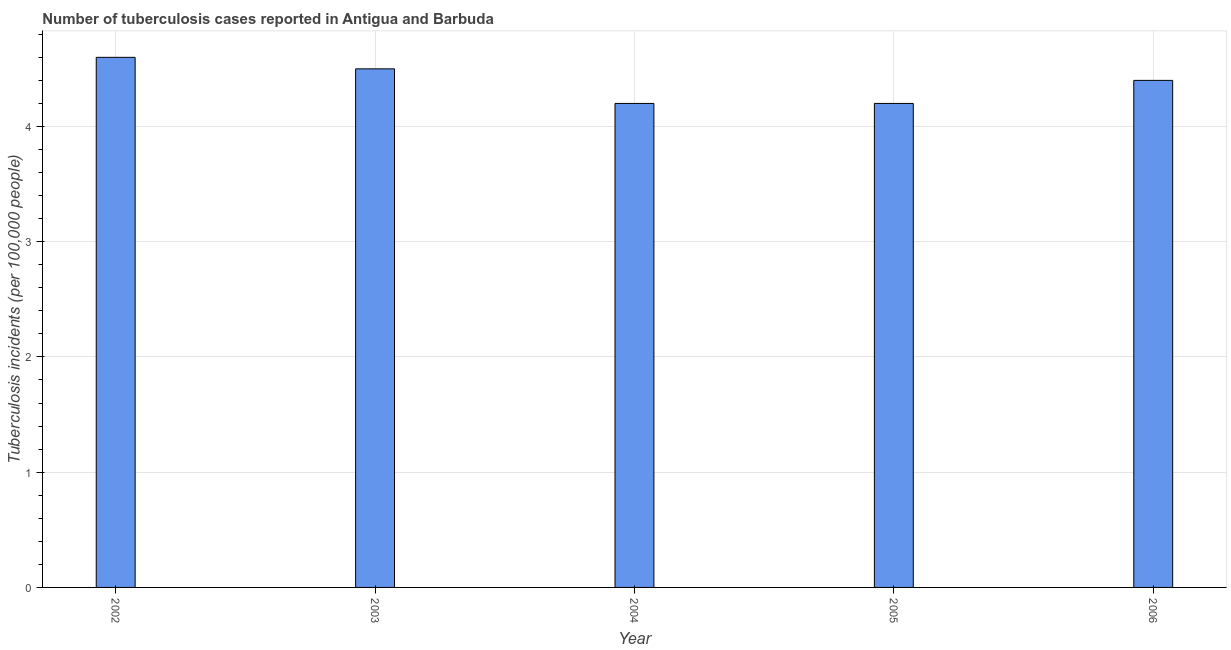Does the graph contain grids?
Your response must be concise. Yes. What is the title of the graph?
Offer a very short reply. Number of tuberculosis cases reported in Antigua and Barbuda. What is the label or title of the X-axis?
Ensure brevity in your answer.  Year. What is the label or title of the Y-axis?
Your answer should be very brief. Tuberculosis incidents (per 100,0 people). Across all years, what is the maximum number of tuberculosis incidents?
Your answer should be very brief. 4.6. Across all years, what is the minimum number of tuberculosis incidents?
Make the answer very short. 4.2. In which year was the number of tuberculosis incidents maximum?
Give a very brief answer. 2002. In which year was the number of tuberculosis incidents minimum?
Keep it short and to the point. 2004. What is the sum of the number of tuberculosis incidents?
Your answer should be compact. 21.9. What is the difference between the number of tuberculosis incidents in 2002 and 2005?
Ensure brevity in your answer.  0.4. What is the average number of tuberculosis incidents per year?
Ensure brevity in your answer.  4.38. What is the ratio of the number of tuberculosis incidents in 2003 to that in 2005?
Offer a terse response. 1.07. Is the number of tuberculosis incidents in 2003 less than that in 2004?
Provide a short and direct response. No. What is the difference between the highest and the second highest number of tuberculosis incidents?
Provide a succinct answer. 0.1. Is the sum of the number of tuberculosis incidents in 2004 and 2005 greater than the maximum number of tuberculosis incidents across all years?
Your answer should be compact. Yes. What is the difference between the highest and the lowest number of tuberculosis incidents?
Offer a terse response. 0.4. In how many years, is the number of tuberculosis incidents greater than the average number of tuberculosis incidents taken over all years?
Ensure brevity in your answer.  3. Are all the bars in the graph horizontal?
Your answer should be compact. No. Are the values on the major ticks of Y-axis written in scientific E-notation?
Offer a very short reply. No. What is the Tuberculosis incidents (per 100,000 people) in 2005?
Your answer should be very brief. 4.2. What is the Tuberculosis incidents (per 100,000 people) in 2006?
Give a very brief answer. 4.4. What is the difference between the Tuberculosis incidents (per 100,000 people) in 2002 and 2003?
Give a very brief answer. 0.1. What is the difference between the Tuberculosis incidents (per 100,000 people) in 2002 and 2004?
Make the answer very short. 0.4. What is the difference between the Tuberculosis incidents (per 100,000 people) in 2003 and 2006?
Offer a very short reply. 0.1. What is the difference between the Tuberculosis incidents (per 100,000 people) in 2004 and 2005?
Make the answer very short. 0. What is the ratio of the Tuberculosis incidents (per 100,000 people) in 2002 to that in 2004?
Make the answer very short. 1.09. What is the ratio of the Tuberculosis incidents (per 100,000 people) in 2002 to that in 2005?
Your response must be concise. 1.09. What is the ratio of the Tuberculosis incidents (per 100,000 people) in 2002 to that in 2006?
Make the answer very short. 1.04. What is the ratio of the Tuberculosis incidents (per 100,000 people) in 2003 to that in 2004?
Provide a succinct answer. 1.07. What is the ratio of the Tuberculosis incidents (per 100,000 people) in 2003 to that in 2005?
Keep it short and to the point. 1.07. What is the ratio of the Tuberculosis incidents (per 100,000 people) in 2003 to that in 2006?
Keep it short and to the point. 1.02. What is the ratio of the Tuberculosis incidents (per 100,000 people) in 2004 to that in 2006?
Your answer should be compact. 0.95. What is the ratio of the Tuberculosis incidents (per 100,000 people) in 2005 to that in 2006?
Give a very brief answer. 0.95. 